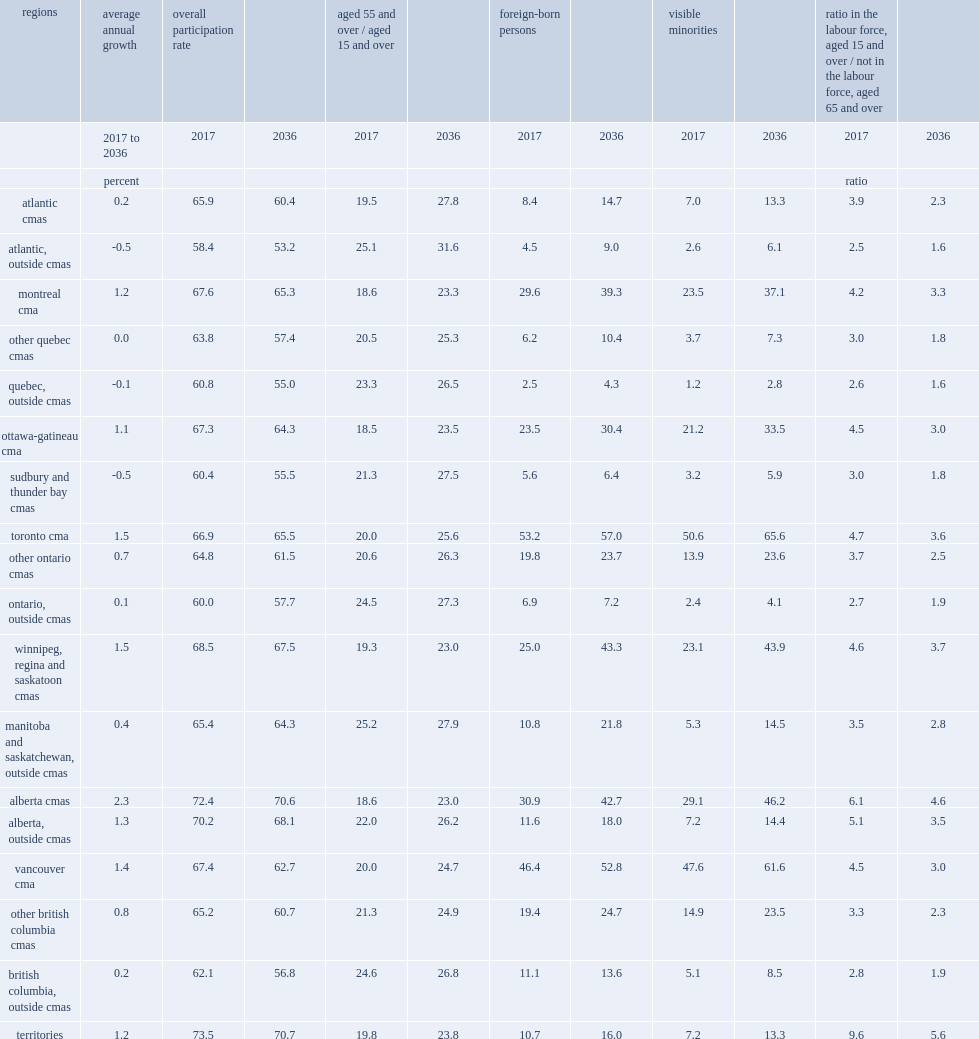In 2036, which regions has the lowest overall participation rate? Atlantic, outside cmas. 